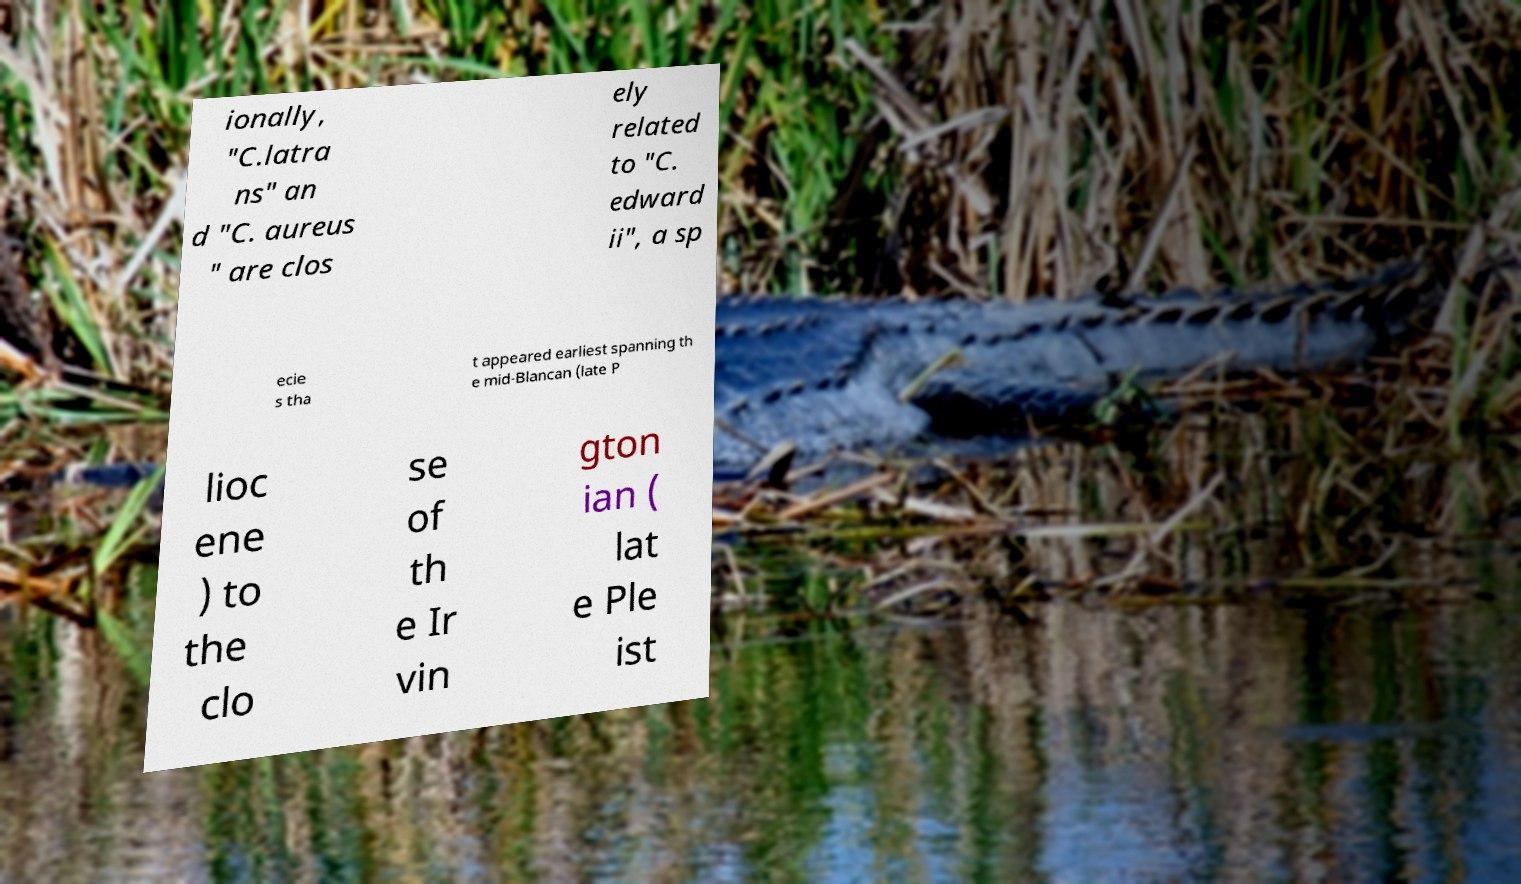Could you extract and type out the text from this image? ionally, "C.latra ns" an d "C. aureus " are clos ely related to "C. edward ii", a sp ecie s tha t appeared earliest spanning th e mid-Blancan (late P lioc ene ) to the clo se of th e Ir vin gton ian ( lat e Ple ist 